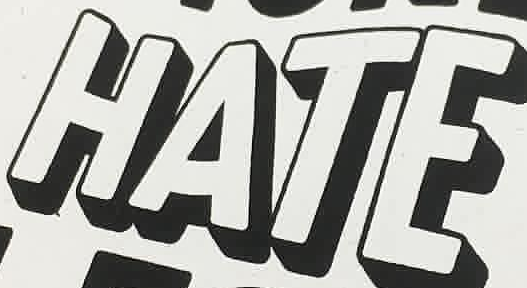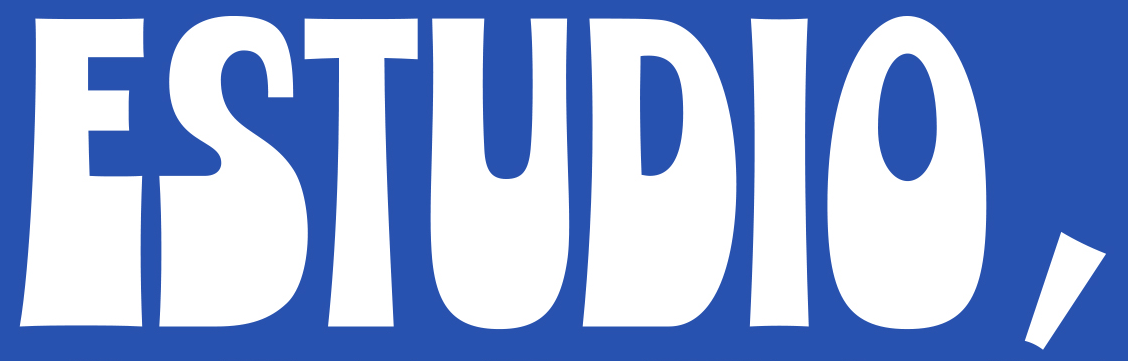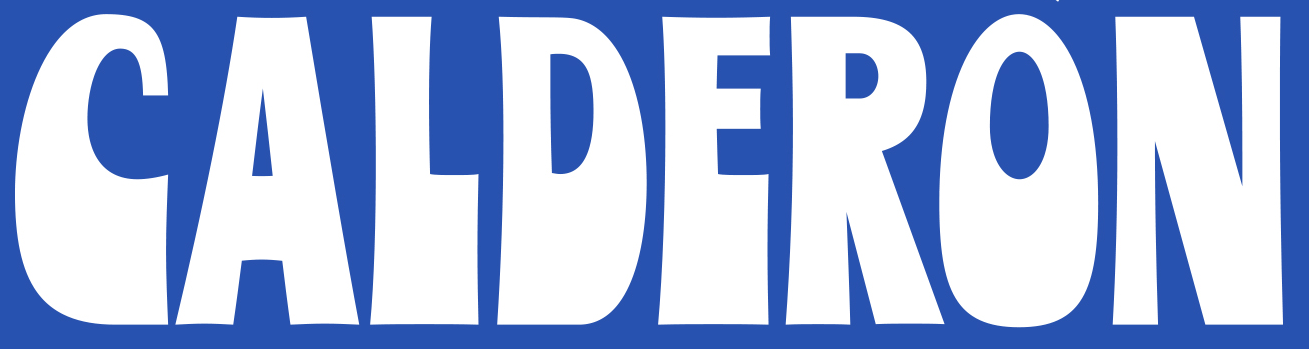What words are shown in these images in order, separated by a semicolon? HATE; ESTUDIO,; CALDERON 